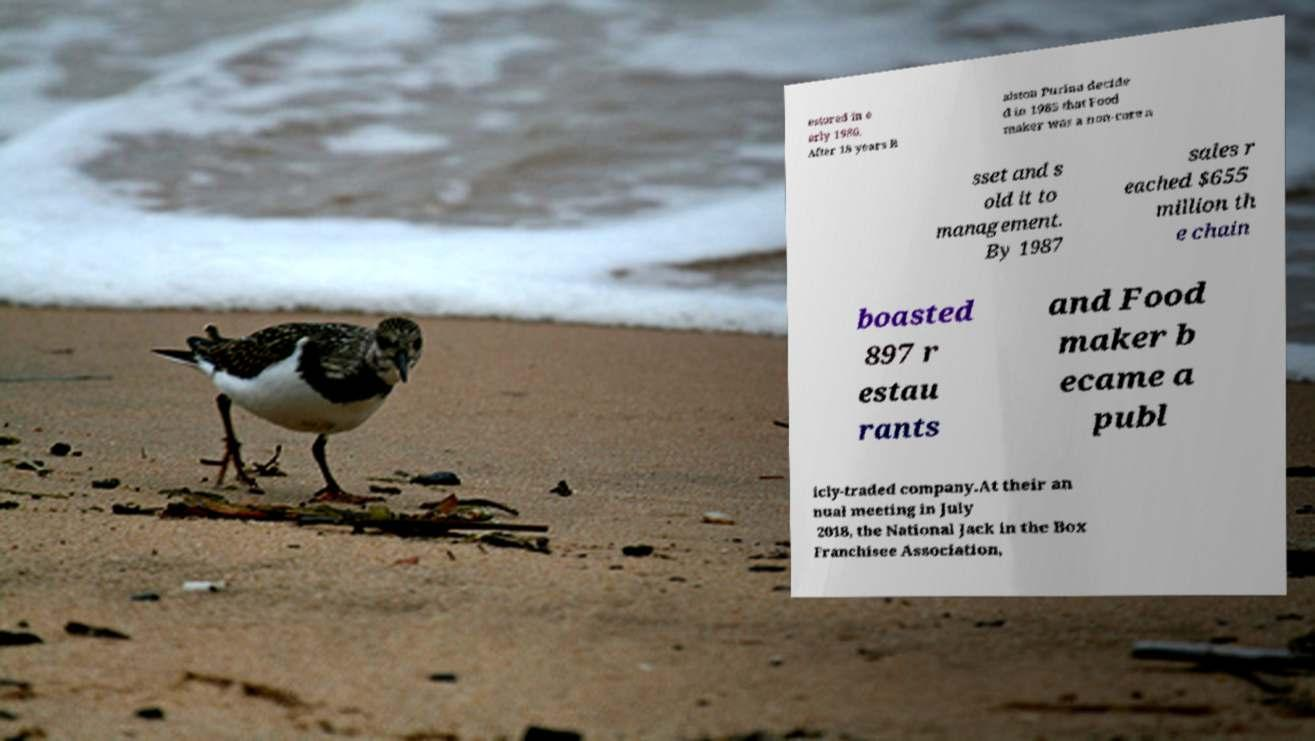I need the written content from this picture converted into text. Can you do that? estored in e arly 1986. After 18 years R alston Purina decide d in 1985 that Food maker was a non-core a sset and s old it to management. By 1987 sales r eached $655 million th e chain boasted 897 r estau rants and Food maker b ecame a publ icly-traded company.At their an nual meeting in July 2018, the National Jack in the Box Franchisee Association, 